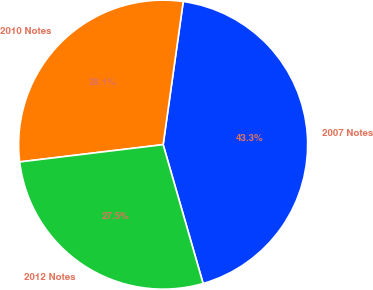Convert chart. <chart><loc_0><loc_0><loc_500><loc_500><pie_chart><fcel>2007 Notes<fcel>2010 Notes<fcel>2012 Notes<nl><fcel>43.32%<fcel>29.13%<fcel>27.55%<nl></chart> 